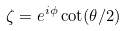<formula> <loc_0><loc_0><loc_500><loc_500>\zeta = e ^ { i \phi } \cot ( \theta / 2 )</formula> 